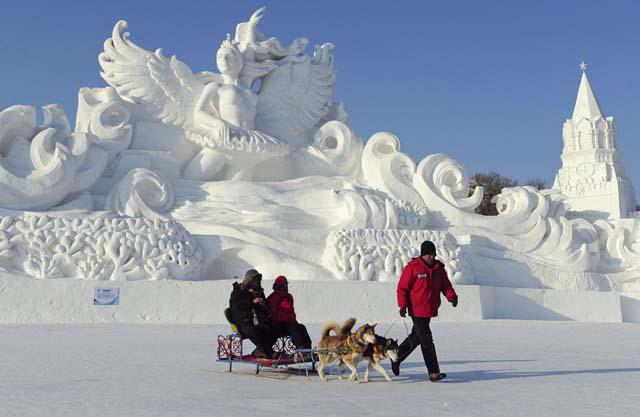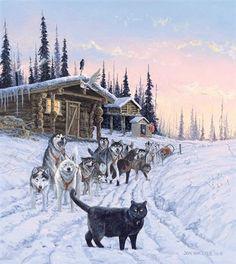The first image is the image on the left, the second image is the image on the right. For the images displayed, is the sentence "Both images contain dogs moving forward." factually correct? Answer yes or no. No. The first image is the image on the left, the second image is the image on the right. For the images displayed, is the sentence "The left image shows a sled dog team moving horizontally to the right, and the right image shows a sled dog team on a path to the right of log cabins." factually correct? Answer yes or no. Yes. 